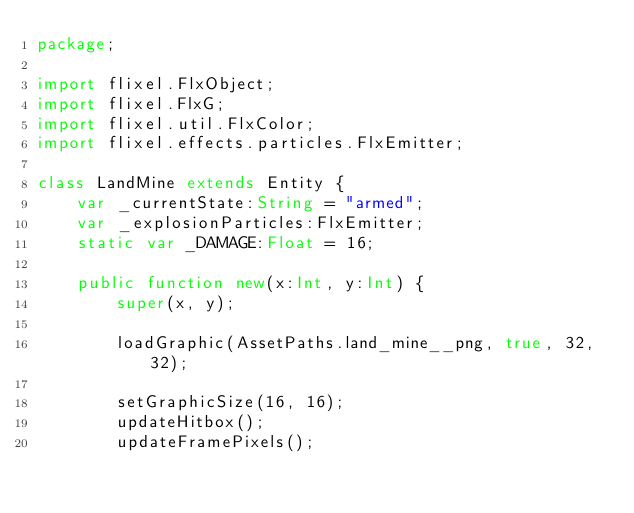Convert code to text. <code><loc_0><loc_0><loc_500><loc_500><_Haxe_>package;

import flixel.FlxObject;
import flixel.FlxG;
import flixel.util.FlxColor;
import flixel.effects.particles.FlxEmitter;

class LandMine extends Entity {
    var _currentState:String = "armed";
    var _explosionParticles:FlxEmitter;
    static var _DAMAGE:Float = 16;

    public function new(x:Int, y:Int) {
        super(x, y);

        loadGraphic(AssetPaths.land_mine__png, true, 32, 32);

        setGraphicSize(16, 16);
        updateHitbox();
        updateFramePixels();
</code> 